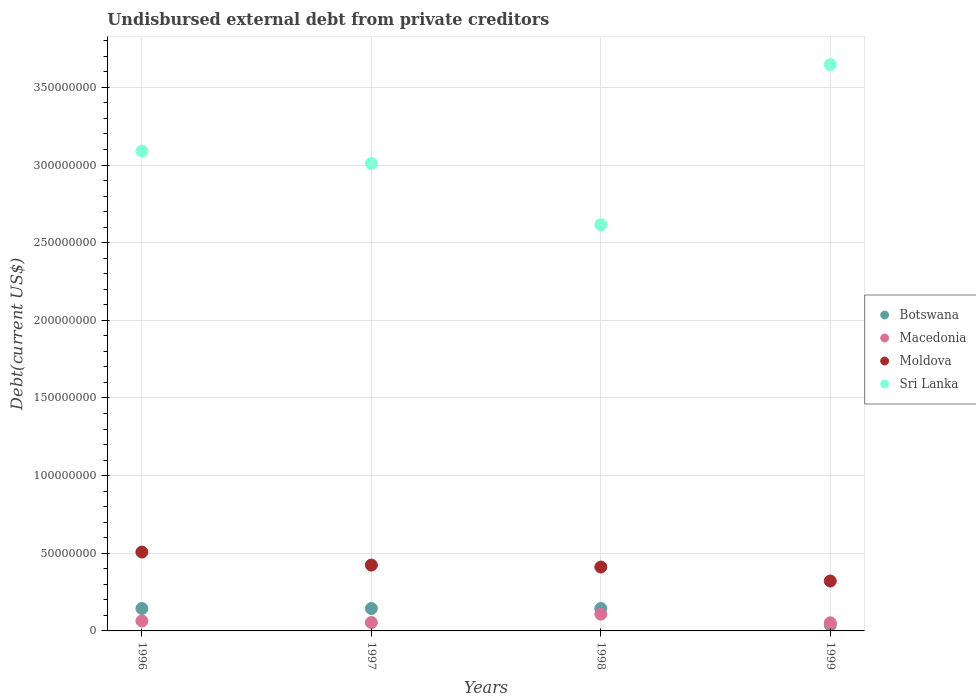How many different coloured dotlines are there?
Offer a terse response. 4. What is the total debt in Sri Lanka in 1996?
Ensure brevity in your answer.  3.09e+08. Across all years, what is the maximum total debt in Moldova?
Provide a short and direct response. 5.08e+07. Across all years, what is the minimum total debt in Sri Lanka?
Give a very brief answer. 2.62e+08. In which year was the total debt in Moldova maximum?
Your answer should be very brief. 1996. In which year was the total debt in Moldova minimum?
Offer a very short reply. 1999. What is the total total debt in Sri Lanka in the graph?
Your answer should be very brief. 1.24e+09. What is the difference between the total debt in Moldova in 1997 and that in 1999?
Keep it short and to the point. 1.03e+07. What is the difference between the total debt in Moldova in 1998 and the total debt in Macedonia in 1996?
Make the answer very short. 3.47e+07. What is the average total debt in Macedonia per year?
Your answer should be compact. 6.96e+06. In the year 1996, what is the difference between the total debt in Macedonia and total debt in Sri Lanka?
Provide a short and direct response. -3.03e+08. In how many years, is the total debt in Moldova greater than 90000000 US$?
Provide a succinct answer. 0. What is the ratio of the total debt in Botswana in 1997 to that in 1999?
Offer a very short reply. 3.83. What is the difference between the highest and the lowest total debt in Macedonia?
Keep it short and to the point. 5.55e+06. Is the sum of the total debt in Sri Lanka in 1996 and 1998 greater than the maximum total debt in Macedonia across all years?
Keep it short and to the point. Yes. Is it the case that in every year, the sum of the total debt in Botswana and total debt in Sri Lanka  is greater than the sum of total debt in Macedonia and total debt in Moldova?
Keep it short and to the point. No. Does the total debt in Sri Lanka monotonically increase over the years?
Provide a short and direct response. No. Is the total debt in Botswana strictly greater than the total debt in Macedonia over the years?
Offer a very short reply. No. Are the values on the major ticks of Y-axis written in scientific E-notation?
Provide a short and direct response. No. Does the graph contain grids?
Ensure brevity in your answer.  Yes. What is the title of the graph?
Your answer should be very brief. Undisbursed external debt from private creditors. Does "Channel Islands" appear as one of the legend labels in the graph?
Your answer should be very brief. No. What is the label or title of the X-axis?
Provide a short and direct response. Years. What is the label or title of the Y-axis?
Your answer should be very brief. Debt(current US$). What is the Debt(current US$) in Botswana in 1996?
Keep it short and to the point. 1.44e+07. What is the Debt(current US$) in Macedonia in 1996?
Your answer should be very brief. 6.43e+06. What is the Debt(current US$) of Moldova in 1996?
Your response must be concise. 5.08e+07. What is the Debt(current US$) of Sri Lanka in 1996?
Make the answer very short. 3.09e+08. What is the Debt(current US$) of Botswana in 1997?
Provide a short and direct response. 1.44e+07. What is the Debt(current US$) in Macedonia in 1997?
Offer a very short reply. 5.40e+06. What is the Debt(current US$) in Moldova in 1997?
Make the answer very short. 4.24e+07. What is the Debt(current US$) in Sri Lanka in 1997?
Give a very brief answer. 3.01e+08. What is the Debt(current US$) of Botswana in 1998?
Ensure brevity in your answer.  1.44e+07. What is the Debt(current US$) in Macedonia in 1998?
Give a very brief answer. 1.08e+07. What is the Debt(current US$) in Moldova in 1998?
Offer a very short reply. 4.11e+07. What is the Debt(current US$) in Sri Lanka in 1998?
Your response must be concise. 2.62e+08. What is the Debt(current US$) of Botswana in 1999?
Provide a short and direct response. 3.77e+06. What is the Debt(current US$) in Macedonia in 1999?
Offer a very short reply. 5.24e+06. What is the Debt(current US$) in Moldova in 1999?
Your response must be concise. 3.21e+07. What is the Debt(current US$) of Sri Lanka in 1999?
Keep it short and to the point. 3.65e+08. Across all years, what is the maximum Debt(current US$) of Botswana?
Give a very brief answer. 1.44e+07. Across all years, what is the maximum Debt(current US$) in Macedonia?
Provide a succinct answer. 1.08e+07. Across all years, what is the maximum Debt(current US$) in Moldova?
Offer a very short reply. 5.08e+07. Across all years, what is the maximum Debt(current US$) of Sri Lanka?
Make the answer very short. 3.65e+08. Across all years, what is the minimum Debt(current US$) of Botswana?
Your answer should be compact. 3.77e+06. Across all years, what is the minimum Debt(current US$) in Macedonia?
Provide a succinct answer. 5.24e+06. Across all years, what is the minimum Debt(current US$) in Moldova?
Offer a terse response. 3.21e+07. Across all years, what is the minimum Debt(current US$) in Sri Lanka?
Ensure brevity in your answer.  2.62e+08. What is the total Debt(current US$) in Botswana in the graph?
Make the answer very short. 4.71e+07. What is the total Debt(current US$) of Macedonia in the graph?
Ensure brevity in your answer.  2.79e+07. What is the total Debt(current US$) of Moldova in the graph?
Provide a succinct answer. 1.66e+08. What is the total Debt(current US$) in Sri Lanka in the graph?
Your response must be concise. 1.24e+09. What is the difference between the Debt(current US$) of Botswana in 1996 and that in 1997?
Ensure brevity in your answer.  0. What is the difference between the Debt(current US$) in Macedonia in 1996 and that in 1997?
Your answer should be compact. 1.03e+06. What is the difference between the Debt(current US$) of Moldova in 1996 and that in 1997?
Your response must be concise. 8.36e+06. What is the difference between the Debt(current US$) of Sri Lanka in 1996 and that in 1997?
Provide a succinct answer. 7.98e+06. What is the difference between the Debt(current US$) in Macedonia in 1996 and that in 1998?
Make the answer very short. -4.36e+06. What is the difference between the Debt(current US$) of Moldova in 1996 and that in 1998?
Your response must be concise. 9.63e+06. What is the difference between the Debt(current US$) in Sri Lanka in 1996 and that in 1998?
Offer a very short reply. 4.75e+07. What is the difference between the Debt(current US$) of Botswana in 1996 and that in 1999?
Your response must be concise. 1.07e+07. What is the difference between the Debt(current US$) in Macedonia in 1996 and that in 1999?
Provide a succinct answer. 1.20e+06. What is the difference between the Debt(current US$) in Moldova in 1996 and that in 1999?
Offer a very short reply. 1.86e+07. What is the difference between the Debt(current US$) of Sri Lanka in 1996 and that in 1999?
Make the answer very short. -5.56e+07. What is the difference between the Debt(current US$) in Botswana in 1997 and that in 1998?
Make the answer very short. 0. What is the difference between the Debt(current US$) of Macedonia in 1997 and that in 1998?
Keep it short and to the point. -5.38e+06. What is the difference between the Debt(current US$) of Moldova in 1997 and that in 1998?
Make the answer very short. 1.27e+06. What is the difference between the Debt(current US$) of Sri Lanka in 1997 and that in 1998?
Your answer should be very brief. 3.95e+07. What is the difference between the Debt(current US$) in Botswana in 1997 and that in 1999?
Give a very brief answer. 1.07e+07. What is the difference between the Debt(current US$) in Macedonia in 1997 and that in 1999?
Offer a terse response. 1.67e+05. What is the difference between the Debt(current US$) of Moldova in 1997 and that in 1999?
Keep it short and to the point. 1.03e+07. What is the difference between the Debt(current US$) in Sri Lanka in 1997 and that in 1999?
Provide a succinct answer. -6.36e+07. What is the difference between the Debt(current US$) in Botswana in 1998 and that in 1999?
Make the answer very short. 1.07e+07. What is the difference between the Debt(current US$) of Macedonia in 1998 and that in 1999?
Offer a terse response. 5.55e+06. What is the difference between the Debt(current US$) in Moldova in 1998 and that in 1999?
Ensure brevity in your answer.  9.01e+06. What is the difference between the Debt(current US$) in Sri Lanka in 1998 and that in 1999?
Keep it short and to the point. -1.03e+08. What is the difference between the Debt(current US$) in Botswana in 1996 and the Debt(current US$) in Macedonia in 1997?
Give a very brief answer. 9.03e+06. What is the difference between the Debt(current US$) in Botswana in 1996 and the Debt(current US$) in Moldova in 1997?
Provide a succinct answer. -2.80e+07. What is the difference between the Debt(current US$) of Botswana in 1996 and the Debt(current US$) of Sri Lanka in 1997?
Provide a succinct answer. -2.87e+08. What is the difference between the Debt(current US$) in Macedonia in 1996 and the Debt(current US$) in Moldova in 1997?
Provide a short and direct response. -3.60e+07. What is the difference between the Debt(current US$) of Macedonia in 1996 and the Debt(current US$) of Sri Lanka in 1997?
Your response must be concise. -2.95e+08. What is the difference between the Debt(current US$) in Moldova in 1996 and the Debt(current US$) in Sri Lanka in 1997?
Provide a short and direct response. -2.50e+08. What is the difference between the Debt(current US$) in Botswana in 1996 and the Debt(current US$) in Macedonia in 1998?
Offer a terse response. 3.64e+06. What is the difference between the Debt(current US$) of Botswana in 1996 and the Debt(current US$) of Moldova in 1998?
Offer a very short reply. -2.67e+07. What is the difference between the Debt(current US$) in Botswana in 1996 and the Debt(current US$) in Sri Lanka in 1998?
Your answer should be very brief. -2.47e+08. What is the difference between the Debt(current US$) in Macedonia in 1996 and the Debt(current US$) in Moldova in 1998?
Your response must be concise. -3.47e+07. What is the difference between the Debt(current US$) in Macedonia in 1996 and the Debt(current US$) in Sri Lanka in 1998?
Offer a terse response. -2.55e+08. What is the difference between the Debt(current US$) of Moldova in 1996 and the Debt(current US$) of Sri Lanka in 1998?
Your response must be concise. -2.11e+08. What is the difference between the Debt(current US$) in Botswana in 1996 and the Debt(current US$) in Macedonia in 1999?
Provide a short and direct response. 9.20e+06. What is the difference between the Debt(current US$) of Botswana in 1996 and the Debt(current US$) of Moldova in 1999?
Keep it short and to the point. -1.77e+07. What is the difference between the Debt(current US$) of Botswana in 1996 and the Debt(current US$) of Sri Lanka in 1999?
Offer a terse response. -3.50e+08. What is the difference between the Debt(current US$) in Macedonia in 1996 and the Debt(current US$) in Moldova in 1999?
Make the answer very short. -2.57e+07. What is the difference between the Debt(current US$) in Macedonia in 1996 and the Debt(current US$) in Sri Lanka in 1999?
Your response must be concise. -3.58e+08. What is the difference between the Debt(current US$) of Moldova in 1996 and the Debt(current US$) of Sri Lanka in 1999?
Provide a succinct answer. -3.14e+08. What is the difference between the Debt(current US$) in Botswana in 1997 and the Debt(current US$) in Macedonia in 1998?
Your answer should be very brief. 3.64e+06. What is the difference between the Debt(current US$) in Botswana in 1997 and the Debt(current US$) in Moldova in 1998?
Provide a succinct answer. -2.67e+07. What is the difference between the Debt(current US$) in Botswana in 1997 and the Debt(current US$) in Sri Lanka in 1998?
Your response must be concise. -2.47e+08. What is the difference between the Debt(current US$) in Macedonia in 1997 and the Debt(current US$) in Moldova in 1998?
Offer a terse response. -3.57e+07. What is the difference between the Debt(current US$) in Macedonia in 1997 and the Debt(current US$) in Sri Lanka in 1998?
Offer a terse response. -2.56e+08. What is the difference between the Debt(current US$) of Moldova in 1997 and the Debt(current US$) of Sri Lanka in 1998?
Your response must be concise. -2.19e+08. What is the difference between the Debt(current US$) in Botswana in 1997 and the Debt(current US$) in Macedonia in 1999?
Your answer should be very brief. 9.20e+06. What is the difference between the Debt(current US$) in Botswana in 1997 and the Debt(current US$) in Moldova in 1999?
Make the answer very short. -1.77e+07. What is the difference between the Debt(current US$) of Botswana in 1997 and the Debt(current US$) of Sri Lanka in 1999?
Offer a terse response. -3.50e+08. What is the difference between the Debt(current US$) in Macedonia in 1997 and the Debt(current US$) in Moldova in 1999?
Make the answer very short. -2.67e+07. What is the difference between the Debt(current US$) in Macedonia in 1997 and the Debt(current US$) in Sri Lanka in 1999?
Offer a very short reply. -3.59e+08. What is the difference between the Debt(current US$) of Moldova in 1997 and the Debt(current US$) of Sri Lanka in 1999?
Offer a very short reply. -3.22e+08. What is the difference between the Debt(current US$) in Botswana in 1998 and the Debt(current US$) in Macedonia in 1999?
Provide a succinct answer. 9.20e+06. What is the difference between the Debt(current US$) of Botswana in 1998 and the Debt(current US$) of Moldova in 1999?
Offer a very short reply. -1.77e+07. What is the difference between the Debt(current US$) of Botswana in 1998 and the Debt(current US$) of Sri Lanka in 1999?
Ensure brevity in your answer.  -3.50e+08. What is the difference between the Debt(current US$) of Macedonia in 1998 and the Debt(current US$) of Moldova in 1999?
Your answer should be very brief. -2.13e+07. What is the difference between the Debt(current US$) of Macedonia in 1998 and the Debt(current US$) of Sri Lanka in 1999?
Ensure brevity in your answer.  -3.54e+08. What is the difference between the Debt(current US$) of Moldova in 1998 and the Debt(current US$) of Sri Lanka in 1999?
Make the answer very short. -3.24e+08. What is the average Debt(current US$) of Botswana per year?
Provide a succinct answer. 1.18e+07. What is the average Debt(current US$) in Macedonia per year?
Your response must be concise. 6.96e+06. What is the average Debt(current US$) in Moldova per year?
Your answer should be compact. 4.16e+07. What is the average Debt(current US$) in Sri Lanka per year?
Make the answer very short. 3.09e+08. In the year 1996, what is the difference between the Debt(current US$) in Botswana and Debt(current US$) in Macedonia?
Your response must be concise. 8.00e+06. In the year 1996, what is the difference between the Debt(current US$) of Botswana and Debt(current US$) of Moldova?
Your response must be concise. -3.63e+07. In the year 1996, what is the difference between the Debt(current US$) of Botswana and Debt(current US$) of Sri Lanka?
Provide a short and direct response. -2.95e+08. In the year 1996, what is the difference between the Debt(current US$) of Macedonia and Debt(current US$) of Moldova?
Provide a succinct answer. -4.43e+07. In the year 1996, what is the difference between the Debt(current US$) in Macedonia and Debt(current US$) in Sri Lanka?
Provide a succinct answer. -3.03e+08. In the year 1996, what is the difference between the Debt(current US$) in Moldova and Debt(current US$) in Sri Lanka?
Offer a terse response. -2.58e+08. In the year 1997, what is the difference between the Debt(current US$) of Botswana and Debt(current US$) of Macedonia?
Your response must be concise. 9.03e+06. In the year 1997, what is the difference between the Debt(current US$) of Botswana and Debt(current US$) of Moldova?
Offer a very short reply. -2.80e+07. In the year 1997, what is the difference between the Debt(current US$) of Botswana and Debt(current US$) of Sri Lanka?
Your answer should be very brief. -2.87e+08. In the year 1997, what is the difference between the Debt(current US$) in Macedonia and Debt(current US$) in Moldova?
Your answer should be very brief. -3.70e+07. In the year 1997, what is the difference between the Debt(current US$) of Macedonia and Debt(current US$) of Sri Lanka?
Keep it short and to the point. -2.96e+08. In the year 1997, what is the difference between the Debt(current US$) of Moldova and Debt(current US$) of Sri Lanka?
Give a very brief answer. -2.59e+08. In the year 1998, what is the difference between the Debt(current US$) in Botswana and Debt(current US$) in Macedonia?
Offer a very short reply. 3.64e+06. In the year 1998, what is the difference between the Debt(current US$) of Botswana and Debt(current US$) of Moldova?
Offer a terse response. -2.67e+07. In the year 1998, what is the difference between the Debt(current US$) of Botswana and Debt(current US$) of Sri Lanka?
Provide a succinct answer. -2.47e+08. In the year 1998, what is the difference between the Debt(current US$) in Macedonia and Debt(current US$) in Moldova?
Offer a very short reply. -3.04e+07. In the year 1998, what is the difference between the Debt(current US$) in Macedonia and Debt(current US$) in Sri Lanka?
Offer a terse response. -2.51e+08. In the year 1998, what is the difference between the Debt(current US$) in Moldova and Debt(current US$) in Sri Lanka?
Offer a very short reply. -2.20e+08. In the year 1999, what is the difference between the Debt(current US$) of Botswana and Debt(current US$) of Macedonia?
Make the answer very short. -1.46e+06. In the year 1999, what is the difference between the Debt(current US$) in Botswana and Debt(current US$) in Moldova?
Keep it short and to the point. -2.84e+07. In the year 1999, what is the difference between the Debt(current US$) in Botswana and Debt(current US$) in Sri Lanka?
Ensure brevity in your answer.  -3.61e+08. In the year 1999, what is the difference between the Debt(current US$) of Macedonia and Debt(current US$) of Moldova?
Offer a terse response. -2.69e+07. In the year 1999, what is the difference between the Debt(current US$) of Macedonia and Debt(current US$) of Sri Lanka?
Your response must be concise. -3.59e+08. In the year 1999, what is the difference between the Debt(current US$) in Moldova and Debt(current US$) in Sri Lanka?
Keep it short and to the point. -3.33e+08. What is the ratio of the Debt(current US$) in Macedonia in 1996 to that in 1997?
Provide a short and direct response. 1.19. What is the ratio of the Debt(current US$) of Moldova in 1996 to that in 1997?
Your answer should be compact. 1.2. What is the ratio of the Debt(current US$) of Sri Lanka in 1996 to that in 1997?
Give a very brief answer. 1.03. What is the ratio of the Debt(current US$) in Macedonia in 1996 to that in 1998?
Offer a terse response. 0.6. What is the ratio of the Debt(current US$) of Moldova in 1996 to that in 1998?
Your response must be concise. 1.23. What is the ratio of the Debt(current US$) of Sri Lanka in 1996 to that in 1998?
Keep it short and to the point. 1.18. What is the ratio of the Debt(current US$) in Botswana in 1996 to that in 1999?
Your answer should be compact. 3.83. What is the ratio of the Debt(current US$) of Macedonia in 1996 to that in 1999?
Make the answer very short. 1.23. What is the ratio of the Debt(current US$) of Moldova in 1996 to that in 1999?
Provide a succinct answer. 1.58. What is the ratio of the Debt(current US$) in Sri Lanka in 1996 to that in 1999?
Keep it short and to the point. 0.85. What is the ratio of the Debt(current US$) of Botswana in 1997 to that in 1998?
Keep it short and to the point. 1. What is the ratio of the Debt(current US$) of Macedonia in 1997 to that in 1998?
Offer a terse response. 0.5. What is the ratio of the Debt(current US$) of Moldova in 1997 to that in 1998?
Your response must be concise. 1.03. What is the ratio of the Debt(current US$) in Sri Lanka in 1997 to that in 1998?
Provide a succinct answer. 1.15. What is the ratio of the Debt(current US$) in Botswana in 1997 to that in 1999?
Give a very brief answer. 3.83. What is the ratio of the Debt(current US$) in Macedonia in 1997 to that in 1999?
Offer a terse response. 1.03. What is the ratio of the Debt(current US$) of Moldova in 1997 to that in 1999?
Offer a terse response. 1.32. What is the ratio of the Debt(current US$) of Sri Lanka in 1997 to that in 1999?
Offer a very short reply. 0.83. What is the ratio of the Debt(current US$) of Botswana in 1998 to that in 1999?
Provide a short and direct response. 3.83. What is the ratio of the Debt(current US$) in Macedonia in 1998 to that in 1999?
Your response must be concise. 2.06. What is the ratio of the Debt(current US$) in Moldova in 1998 to that in 1999?
Your answer should be very brief. 1.28. What is the ratio of the Debt(current US$) in Sri Lanka in 1998 to that in 1999?
Offer a very short reply. 0.72. What is the difference between the highest and the second highest Debt(current US$) in Macedonia?
Your response must be concise. 4.36e+06. What is the difference between the highest and the second highest Debt(current US$) of Moldova?
Ensure brevity in your answer.  8.36e+06. What is the difference between the highest and the second highest Debt(current US$) of Sri Lanka?
Offer a terse response. 5.56e+07. What is the difference between the highest and the lowest Debt(current US$) of Botswana?
Provide a short and direct response. 1.07e+07. What is the difference between the highest and the lowest Debt(current US$) in Macedonia?
Your response must be concise. 5.55e+06. What is the difference between the highest and the lowest Debt(current US$) in Moldova?
Your response must be concise. 1.86e+07. What is the difference between the highest and the lowest Debt(current US$) of Sri Lanka?
Provide a succinct answer. 1.03e+08. 